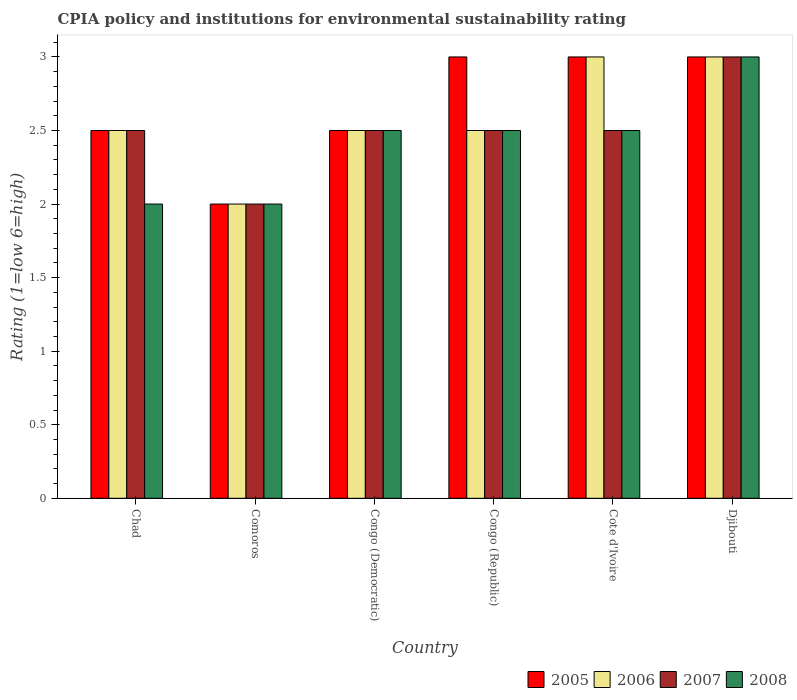How many different coloured bars are there?
Keep it short and to the point. 4. Are the number of bars per tick equal to the number of legend labels?
Give a very brief answer. Yes. How many bars are there on the 2nd tick from the left?
Offer a very short reply. 4. How many bars are there on the 2nd tick from the right?
Ensure brevity in your answer.  4. What is the label of the 5th group of bars from the left?
Provide a short and direct response. Cote d'Ivoire. In how many cases, is the number of bars for a given country not equal to the number of legend labels?
Offer a terse response. 0. What is the CPIA rating in 2005 in Congo (Democratic)?
Offer a very short reply. 2.5. Across all countries, what is the maximum CPIA rating in 2008?
Offer a very short reply. 3. In which country was the CPIA rating in 2006 maximum?
Make the answer very short. Cote d'Ivoire. In which country was the CPIA rating in 2006 minimum?
Offer a terse response. Comoros. What is the total CPIA rating in 2006 in the graph?
Offer a terse response. 15.5. What is the difference between the CPIA rating in 2007 in Djibouti and the CPIA rating in 2006 in Comoros?
Ensure brevity in your answer.  1. What is the average CPIA rating in 2008 per country?
Provide a succinct answer. 2.42. What is the ratio of the CPIA rating in 2007 in Chad to that in Congo (Republic)?
Keep it short and to the point. 1. Is the difference between the CPIA rating in 2005 in Comoros and Congo (Republic) greater than the difference between the CPIA rating in 2007 in Comoros and Congo (Republic)?
Provide a short and direct response. No. What is the difference between the highest and the second highest CPIA rating in 2008?
Provide a short and direct response. -0.5. In how many countries, is the CPIA rating in 2007 greater than the average CPIA rating in 2007 taken over all countries?
Offer a terse response. 1. What does the 1st bar from the left in Comoros represents?
Your answer should be compact. 2005. What does the 3rd bar from the right in Chad represents?
Provide a succinct answer. 2006. Is it the case that in every country, the sum of the CPIA rating in 2007 and CPIA rating in 2006 is greater than the CPIA rating in 2005?
Ensure brevity in your answer.  Yes. Are all the bars in the graph horizontal?
Offer a terse response. No. What is the difference between two consecutive major ticks on the Y-axis?
Your answer should be very brief. 0.5. Are the values on the major ticks of Y-axis written in scientific E-notation?
Offer a terse response. No. How many legend labels are there?
Make the answer very short. 4. How are the legend labels stacked?
Offer a very short reply. Horizontal. What is the title of the graph?
Your answer should be very brief. CPIA policy and institutions for environmental sustainability rating. What is the label or title of the X-axis?
Make the answer very short. Country. What is the Rating (1=low 6=high) in 2005 in Chad?
Make the answer very short. 2.5. What is the Rating (1=low 6=high) of 2007 in Chad?
Offer a terse response. 2.5. What is the Rating (1=low 6=high) of 2008 in Chad?
Your response must be concise. 2. What is the Rating (1=low 6=high) in 2005 in Comoros?
Ensure brevity in your answer.  2. What is the Rating (1=low 6=high) in 2006 in Comoros?
Provide a succinct answer. 2. What is the Rating (1=low 6=high) of 2007 in Comoros?
Offer a very short reply. 2. What is the Rating (1=low 6=high) of 2008 in Congo (Democratic)?
Offer a terse response. 2.5. What is the Rating (1=low 6=high) in 2005 in Congo (Republic)?
Provide a succinct answer. 3. What is the Rating (1=low 6=high) of 2005 in Cote d'Ivoire?
Provide a short and direct response. 3. What is the Rating (1=low 6=high) of 2006 in Cote d'Ivoire?
Make the answer very short. 3. What is the Rating (1=low 6=high) in 2007 in Cote d'Ivoire?
Provide a succinct answer. 2.5. Across all countries, what is the maximum Rating (1=low 6=high) of 2007?
Give a very brief answer. 3. Across all countries, what is the maximum Rating (1=low 6=high) of 2008?
Your answer should be very brief. 3. Across all countries, what is the minimum Rating (1=low 6=high) in 2005?
Make the answer very short. 2. Across all countries, what is the minimum Rating (1=low 6=high) of 2008?
Your answer should be compact. 2. What is the total Rating (1=low 6=high) in 2005 in the graph?
Your answer should be compact. 16. What is the total Rating (1=low 6=high) in 2008 in the graph?
Make the answer very short. 14.5. What is the difference between the Rating (1=low 6=high) in 2005 in Chad and that in Comoros?
Your answer should be very brief. 0.5. What is the difference between the Rating (1=low 6=high) of 2006 in Chad and that in Comoros?
Make the answer very short. 0.5. What is the difference between the Rating (1=low 6=high) of 2007 in Chad and that in Comoros?
Provide a short and direct response. 0.5. What is the difference between the Rating (1=low 6=high) in 2008 in Chad and that in Comoros?
Ensure brevity in your answer.  0. What is the difference between the Rating (1=low 6=high) of 2006 in Chad and that in Congo (Republic)?
Give a very brief answer. 0. What is the difference between the Rating (1=low 6=high) of 2008 in Chad and that in Congo (Republic)?
Ensure brevity in your answer.  -0.5. What is the difference between the Rating (1=low 6=high) of 2005 in Chad and that in Cote d'Ivoire?
Provide a succinct answer. -0.5. What is the difference between the Rating (1=low 6=high) in 2007 in Chad and that in Cote d'Ivoire?
Offer a terse response. 0. What is the difference between the Rating (1=low 6=high) of 2005 in Comoros and that in Congo (Democratic)?
Offer a very short reply. -0.5. What is the difference between the Rating (1=low 6=high) in 2006 in Comoros and that in Congo (Democratic)?
Offer a very short reply. -0.5. What is the difference between the Rating (1=low 6=high) of 2008 in Comoros and that in Congo (Democratic)?
Offer a very short reply. -0.5. What is the difference between the Rating (1=low 6=high) in 2005 in Comoros and that in Congo (Republic)?
Ensure brevity in your answer.  -1. What is the difference between the Rating (1=low 6=high) of 2006 in Comoros and that in Congo (Republic)?
Your answer should be very brief. -0.5. What is the difference between the Rating (1=low 6=high) in 2007 in Comoros and that in Congo (Republic)?
Offer a terse response. -0.5. What is the difference between the Rating (1=low 6=high) of 2008 in Comoros and that in Congo (Republic)?
Offer a very short reply. -0.5. What is the difference between the Rating (1=low 6=high) in 2005 in Comoros and that in Cote d'Ivoire?
Provide a succinct answer. -1. What is the difference between the Rating (1=low 6=high) in 2006 in Comoros and that in Cote d'Ivoire?
Your answer should be compact. -1. What is the difference between the Rating (1=low 6=high) of 2007 in Comoros and that in Djibouti?
Keep it short and to the point. -1. What is the difference between the Rating (1=low 6=high) in 2008 in Comoros and that in Djibouti?
Keep it short and to the point. -1. What is the difference between the Rating (1=low 6=high) in 2005 in Congo (Democratic) and that in Congo (Republic)?
Offer a very short reply. -0.5. What is the difference between the Rating (1=low 6=high) of 2006 in Congo (Democratic) and that in Congo (Republic)?
Your answer should be compact. 0. What is the difference between the Rating (1=low 6=high) in 2006 in Congo (Democratic) and that in Cote d'Ivoire?
Your response must be concise. -0.5. What is the difference between the Rating (1=low 6=high) of 2007 in Congo (Democratic) and that in Cote d'Ivoire?
Give a very brief answer. 0. What is the difference between the Rating (1=low 6=high) of 2008 in Congo (Democratic) and that in Cote d'Ivoire?
Make the answer very short. 0. What is the difference between the Rating (1=low 6=high) of 2005 in Congo (Democratic) and that in Djibouti?
Provide a short and direct response. -0.5. What is the difference between the Rating (1=low 6=high) in 2007 in Congo (Democratic) and that in Djibouti?
Provide a succinct answer. -0.5. What is the difference between the Rating (1=low 6=high) of 2005 in Congo (Republic) and that in Cote d'Ivoire?
Provide a short and direct response. 0. What is the difference between the Rating (1=low 6=high) of 2005 in Congo (Republic) and that in Djibouti?
Provide a succinct answer. 0. What is the difference between the Rating (1=low 6=high) in 2008 in Congo (Republic) and that in Djibouti?
Provide a succinct answer. -0.5. What is the difference between the Rating (1=low 6=high) in 2005 in Cote d'Ivoire and that in Djibouti?
Your response must be concise. 0. What is the difference between the Rating (1=low 6=high) in 2005 in Chad and the Rating (1=low 6=high) in 2007 in Comoros?
Make the answer very short. 0.5. What is the difference between the Rating (1=low 6=high) of 2005 in Chad and the Rating (1=low 6=high) of 2008 in Comoros?
Make the answer very short. 0.5. What is the difference between the Rating (1=low 6=high) in 2006 in Chad and the Rating (1=low 6=high) in 2008 in Comoros?
Your response must be concise. 0.5. What is the difference between the Rating (1=low 6=high) of 2005 in Chad and the Rating (1=low 6=high) of 2006 in Congo (Democratic)?
Give a very brief answer. 0. What is the difference between the Rating (1=low 6=high) of 2005 in Chad and the Rating (1=low 6=high) of 2007 in Congo (Democratic)?
Give a very brief answer. 0. What is the difference between the Rating (1=low 6=high) in 2005 in Chad and the Rating (1=low 6=high) in 2008 in Congo (Democratic)?
Offer a very short reply. 0. What is the difference between the Rating (1=low 6=high) in 2006 in Chad and the Rating (1=low 6=high) in 2007 in Congo (Democratic)?
Provide a succinct answer. 0. What is the difference between the Rating (1=low 6=high) in 2006 in Chad and the Rating (1=low 6=high) in 2008 in Congo (Democratic)?
Your answer should be very brief. 0. What is the difference between the Rating (1=low 6=high) of 2005 in Chad and the Rating (1=low 6=high) of 2007 in Congo (Republic)?
Give a very brief answer. 0. What is the difference between the Rating (1=low 6=high) of 2006 in Chad and the Rating (1=low 6=high) of 2007 in Congo (Republic)?
Make the answer very short. 0. What is the difference between the Rating (1=low 6=high) in 2006 in Chad and the Rating (1=low 6=high) in 2008 in Congo (Republic)?
Give a very brief answer. 0. What is the difference between the Rating (1=low 6=high) in 2005 in Chad and the Rating (1=low 6=high) in 2006 in Cote d'Ivoire?
Make the answer very short. -0.5. What is the difference between the Rating (1=low 6=high) of 2005 in Chad and the Rating (1=low 6=high) of 2007 in Cote d'Ivoire?
Give a very brief answer. 0. What is the difference between the Rating (1=low 6=high) in 2005 in Chad and the Rating (1=low 6=high) in 2008 in Cote d'Ivoire?
Make the answer very short. 0. What is the difference between the Rating (1=low 6=high) in 2006 in Chad and the Rating (1=low 6=high) in 2008 in Cote d'Ivoire?
Ensure brevity in your answer.  0. What is the difference between the Rating (1=low 6=high) in 2005 in Chad and the Rating (1=low 6=high) in 2007 in Djibouti?
Keep it short and to the point. -0.5. What is the difference between the Rating (1=low 6=high) of 2006 in Comoros and the Rating (1=low 6=high) of 2007 in Congo (Democratic)?
Provide a succinct answer. -0.5. What is the difference between the Rating (1=low 6=high) of 2007 in Comoros and the Rating (1=low 6=high) of 2008 in Congo (Democratic)?
Keep it short and to the point. -0.5. What is the difference between the Rating (1=low 6=high) of 2005 in Comoros and the Rating (1=low 6=high) of 2006 in Congo (Republic)?
Offer a very short reply. -0.5. What is the difference between the Rating (1=low 6=high) of 2005 in Comoros and the Rating (1=low 6=high) of 2007 in Congo (Republic)?
Your answer should be very brief. -0.5. What is the difference between the Rating (1=low 6=high) in 2007 in Comoros and the Rating (1=low 6=high) in 2008 in Congo (Republic)?
Offer a terse response. -0.5. What is the difference between the Rating (1=low 6=high) in 2006 in Comoros and the Rating (1=low 6=high) in 2007 in Cote d'Ivoire?
Give a very brief answer. -0.5. What is the difference between the Rating (1=low 6=high) in 2006 in Comoros and the Rating (1=low 6=high) in 2008 in Cote d'Ivoire?
Give a very brief answer. -0.5. What is the difference between the Rating (1=low 6=high) in 2007 in Comoros and the Rating (1=low 6=high) in 2008 in Cote d'Ivoire?
Offer a terse response. -0.5. What is the difference between the Rating (1=low 6=high) of 2005 in Comoros and the Rating (1=low 6=high) of 2006 in Djibouti?
Your answer should be very brief. -1. What is the difference between the Rating (1=low 6=high) of 2005 in Comoros and the Rating (1=low 6=high) of 2007 in Djibouti?
Offer a very short reply. -1. What is the difference between the Rating (1=low 6=high) in 2005 in Comoros and the Rating (1=low 6=high) in 2008 in Djibouti?
Ensure brevity in your answer.  -1. What is the difference between the Rating (1=low 6=high) of 2006 in Comoros and the Rating (1=low 6=high) of 2008 in Djibouti?
Ensure brevity in your answer.  -1. What is the difference between the Rating (1=low 6=high) in 2005 in Congo (Democratic) and the Rating (1=low 6=high) in 2006 in Congo (Republic)?
Keep it short and to the point. 0. What is the difference between the Rating (1=low 6=high) of 2006 in Congo (Democratic) and the Rating (1=low 6=high) of 2008 in Congo (Republic)?
Keep it short and to the point. 0. What is the difference between the Rating (1=low 6=high) in 2005 in Congo (Democratic) and the Rating (1=low 6=high) in 2006 in Cote d'Ivoire?
Your answer should be very brief. -0.5. What is the difference between the Rating (1=low 6=high) of 2005 in Congo (Democratic) and the Rating (1=low 6=high) of 2007 in Cote d'Ivoire?
Your response must be concise. 0. What is the difference between the Rating (1=low 6=high) in 2007 in Congo (Democratic) and the Rating (1=low 6=high) in 2008 in Cote d'Ivoire?
Provide a succinct answer. 0. What is the difference between the Rating (1=low 6=high) in 2005 in Congo (Democratic) and the Rating (1=low 6=high) in 2007 in Djibouti?
Make the answer very short. -0.5. What is the difference between the Rating (1=low 6=high) in 2007 in Congo (Democratic) and the Rating (1=low 6=high) in 2008 in Djibouti?
Your answer should be compact. -0.5. What is the difference between the Rating (1=low 6=high) of 2005 in Congo (Republic) and the Rating (1=low 6=high) of 2008 in Cote d'Ivoire?
Your answer should be compact. 0.5. What is the difference between the Rating (1=low 6=high) in 2005 in Congo (Republic) and the Rating (1=low 6=high) in 2008 in Djibouti?
Your response must be concise. 0. What is the difference between the Rating (1=low 6=high) in 2006 in Congo (Republic) and the Rating (1=low 6=high) in 2007 in Djibouti?
Make the answer very short. -0.5. What is the difference between the Rating (1=low 6=high) of 2007 in Congo (Republic) and the Rating (1=low 6=high) of 2008 in Djibouti?
Your answer should be compact. -0.5. What is the difference between the Rating (1=low 6=high) in 2005 in Cote d'Ivoire and the Rating (1=low 6=high) in 2006 in Djibouti?
Ensure brevity in your answer.  0. What is the difference between the Rating (1=low 6=high) in 2005 in Cote d'Ivoire and the Rating (1=low 6=high) in 2008 in Djibouti?
Your response must be concise. 0. What is the difference between the Rating (1=low 6=high) of 2006 in Cote d'Ivoire and the Rating (1=low 6=high) of 2008 in Djibouti?
Offer a very short reply. 0. What is the difference between the Rating (1=low 6=high) in 2007 in Cote d'Ivoire and the Rating (1=low 6=high) in 2008 in Djibouti?
Offer a very short reply. -0.5. What is the average Rating (1=low 6=high) of 2005 per country?
Your response must be concise. 2.67. What is the average Rating (1=low 6=high) in 2006 per country?
Your answer should be compact. 2.58. What is the average Rating (1=low 6=high) in 2008 per country?
Provide a succinct answer. 2.42. What is the difference between the Rating (1=low 6=high) of 2006 and Rating (1=low 6=high) of 2007 in Chad?
Offer a terse response. 0. What is the difference between the Rating (1=low 6=high) of 2007 and Rating (1=low 6=high) of 2008 in Chad?
Provide a short and direct response. 0.5. What is the difference between the Rating (1=low 6=high) of 2005 and Rating (1=low 6=high) of 2007 in Comoros?
Your answer should be very brief. 0. What is the difference between the Rating (1=low 6=high) of 2005 and Rating (1=low 6=high) of 2008 in Comoros?
Offer a terse response. 0. What is the difference between the Rating (1=low 6=high) in 2006 and Rating (1=low 6=high) in 2008 in Comoros?
Ensure brevity in your answer.  0. What is the difference between the Rating (1=low 6=high) in 2007 and Rating (1=low 6=high) in 2008 in Comoros?
Your response must be concise. 0. What is the difference between the Rating (1=low 6=high) of 2007 and Rating (1=low 6=high) of 2008 in Congo (Democratic)?
Your response must be concise. 0. What is the difference between the Rating (1=low 6=high) in 2005 and Rating (1=low 6=high) in 2007 in Congo (Republic)?
Your response must be concise. 0.5. What is the difference between the Rating (1=low 6=high) of 2005 and Rating (1=low 6=high) of 2006 in Cote d'Ivoire?
Your answer should be compact. 0. What is the difference between the Rating (1=low 6=high) of 2005 and Rating (1=low 6=high) of 2007 in Cote d'Ivoire?
Your response must be concise. 0.5. What is the difference between the Rating (1=low 6=high) of 2006 and Rating (1=low 6=high) of 2007 in Cote d'Ivoire?
Offer a terse response. 0.5. What is the difference between the Rating (1=low 6=high) of 2007 and Rating (1=low 6=high) of 2008 in Cote d'Ivoire?
Offer a very short reply. 0. What is the difference between the Rating (1=low 6=high) in 2005 and Rating (1=low 6=high) in 2006 in Djibouti?
Provide a short and direct response. 0. What is the difference between the Rating (1=low 6=high) of 2005 and Rating (1=low 6=high) of 2007 in Djibouti?
Provide a succinct answer. 0. What is the difference between the Rating (1=low 6=high) in 2005 and Rating (1=low 6=high) in 2008 in Djibouti?
Your answer should be very brief. 0. What is the difference between the Rating (1=low 6=high) in 2006 and Rating (1=low 6=high) in 2007 in Djibouti?
Provide a short and direct response. 0. What is the difference between the Rating (1=low 6=high) of 2006 and Rating (1=low 6=high) of 2008 in Djibouti?
Offer a very short reply. 0. What is the difference between the Rating (1=low 6=high) of 2007 and Rating (1=low 6=high) of 2008 in Djibouti?
Your answer should be very brief. 0. What is the ratio of the Rating (1=low 6=high) in 2005 in Chad to that in Comoros?
Keep it short and to the point. 1.25. What is the ratio of the Rating (1=low 6=high) in 2005 in Chad to that in Congo (Democratic)?
Make the answer very short. 1. What is the ratio of the Rating (1=low 6=high) of 2005 in Chad to that in Cote d'Ivoire?
Keep it short and to the point. 0.83. What is the ratio of the Rating (1=low 6=high) in 2007 in Chad to that in Cote d'Ivoire?
Offer a very short reply. 1. What is the ratio of the Rating (1=low 6=high) in 2005 in Chad to that in Djibouti?
Your response must be concise. 0.83. What is the ratio of the Rating (1=low 6=high) in 2007 in Chad to that in Djibouti?
Your answer should be very brief. 0.83. What is the ratio of the Rating (1=low 6=high) in 2008 in Comoros to that in Congo (Republic)?
Your answer should be very brief. 0.8. What is the ratio of the Rating (1=low 6=high) of 2005 in Comoros to that in Cote d'Ivoire?
Offer a terse response. 0.67. What is the ratio of the Rating (1=low 6=high) of 2007 in Comoros to that in Djibouti?
Your answer should be very brief. 0.67. What is the ratio of the Rating (1=low 6=high) in 2008 in Comoros to that in Djibouti?
Offer a terse response. 0.67. What is the ratio of the Rating (1=low 6=high) of 2005 in Congo (Democratic) to that in Congo (Republic)?
Offer a very short reply. 0.83. What is the ratio of the Rating (1=low 6=high) in 2006 in Congo (Democratic) to that in Congo (Republic)?
Ensure brevity in your answer.  1. What is the ratio of the Rating (1=low 6=high) in 2007 in Congo (Democratic) to that in Congo (Republic)?
Your answer should be very brief. 1. What is the ratio of the Rating (1=low 6=high) of 2008 in Congo (Democratic) to that in Congo (Republic)?
Ensure brevity in your answer.  1. What is the ratio of the Rating (1=low 6=high) of 2006 in Congo (Democratic) to that in Cote d'Ivoire?
Keep it short and to the point. 0.83. What is the ratio of the Rating (1=low 6=high) in 2008 in Congo (Democratic) to that in Cote d'Ivoire?
Make the answer very short. 1. What is the ratio of the Rating (1=low 6=high) in 2005 in Congo (Democratic) to that in Djibouti?
Offer a very short reply. 0.83. What is the ratio of the Rating (1=low 6=high) in 2007 in Congo (Democratic) to that in Djibouti?
Offer a very short reply. 0.83. What is the ratio of the Rating (1=low 6=high) in 2008 in Congo (Democratic) to that in Djibouti?
Your answer should be very brief. 0.83. What is the ratio of the Rating (1=low 6=high) in 2006 in Congo (Republic) to that in Cote d'Ivoire?
Make the answer very short. 0.83. What is the ratio of the Rating (1=low 6=high) of 2007 in Congo (Republic) to that in Cote d'Ivoire?
Make the answer very short. 1. What is the ratio of the Rating (1=low 6=high) of 2005 in Congo (Republic) to that in Djibouti?
Your response must be concise. 1. What is the ratio of the Rating (1=low 6=high) of 2006 in Congo (Republic) to that in Djibouti?
Ensure brevity in your answer.  0.83. What is the ratio of the Rating (1=low 6=high) of 2007 in Congo (Republic) to that in Djibouti?
Your response must be concise. 0.83. What is the ratio of the Rating (1=low 6=high) of 2005 in Cote d'Ivoire to that in Djibouti?
Keep it short and to the point. 1. What is the ratio of the Rating (1=low 6=high) in 2007 in Cote d'Ivoire to that in Djibouti?
Offer a very short reply. 0.83. What is the difference between the highest and the second highest Rating (1=low 6=high) in 2005?
Offer a very short reply. 0. What is the difference between the highest and the second highest Rating (1=low 6=high) in 2007?
Your answer should be very brief. 0.5. What is the difference between the highest and the lowest Rating (1=low 6=high) of 2008?
Offer a very short reply. 1. 